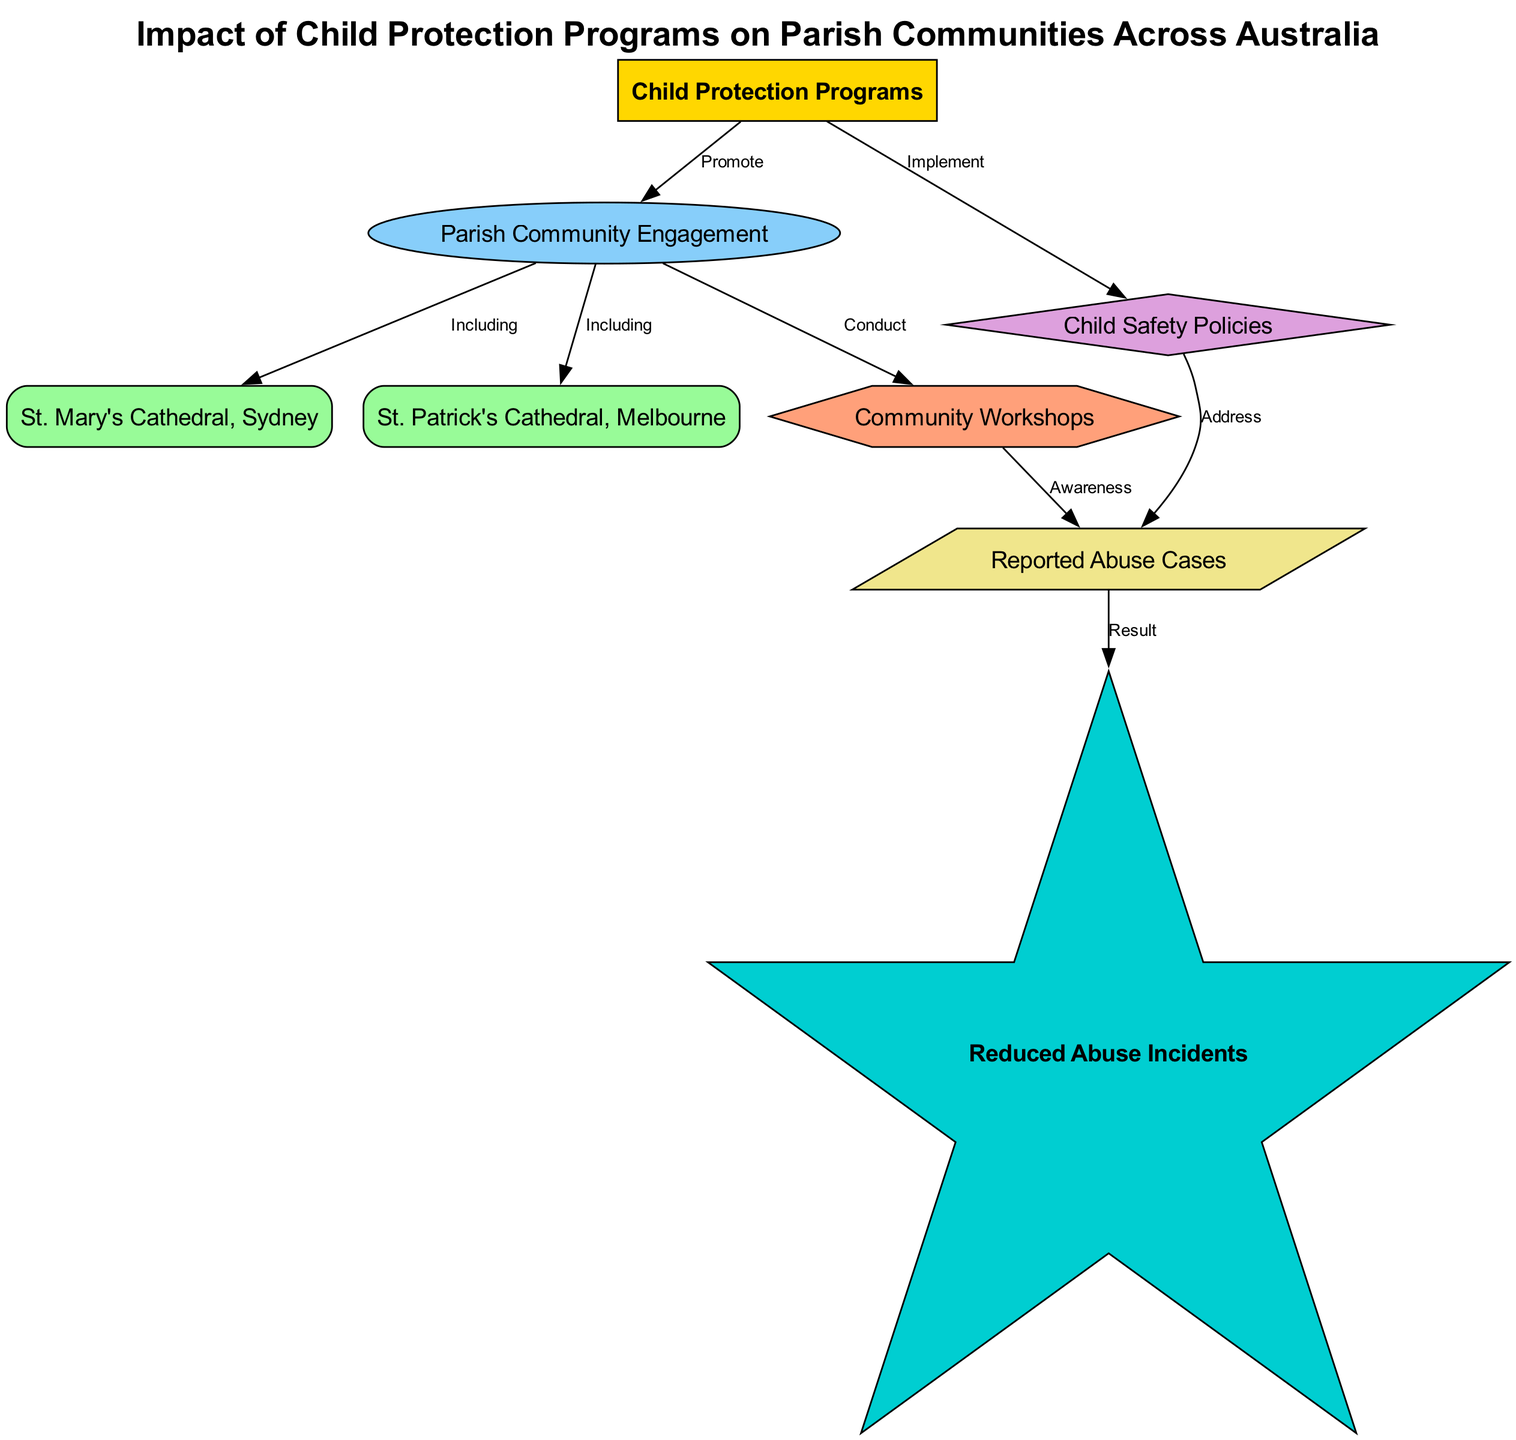What is the main node in the diagram? The main node in the diagram is identified as "Child Protection Programs," as it serves as the starting point for the relationships presented in the diagram.
Answer: Child Protection Programs How many example nodes are there? The diagram includes two example nodes: "St. Mary's Cathedral, Sydney" and "St. Patrick's Cathedral, Melbourne." Therefore, the total count of example nodes is two.
Answer: 2 What type of node is "Community Workshops"? In the diagram, "Community Workshops" is categorized as an "activity" node, indicating its role in the context of child protection programs.
Answer: activity Which node demonstrates a direct outcome of reported abuse cases? The node "Reduced Abuse Incidents" directly follows the node "Reported Abuse Cases," showing that it is an outcome resulting from efforts to address reported abuse.
Answer: Reduced Abuse Incidents What is the relationship between "Child Protection Programs" and "Child Safety Policies"? The diagram shows that "Child Protection Programs" implement "Child Safety Policies," indicating a direct action of the main node on the policy node.
Answer: Implement How does "Community Workshops" relate to "Reported Abuse Cases"? "Community Workshops" conducts activities that raise awareness, which in turn addresses "Reported Abuse Cases." Hence, there is a two-step connection between these nodes where awareness leads to addressing abuse cases.
Answer: Awareness What is the last node in the flow of the diagram? The last node in the flow of the diagram is "Reduced Abuse Incidents," which emerges from the relationships established in preceding nodes and signifies the ultimate goal of the program's impact.
Answer: Reduced Abuse Incidents Which two parishes are included in the community engagement category? The two parishes included in the community engagement category are "St. Mary's Cathedral, Sydney" and "St. Patrick's Cathedral, Melbourne," both of which are explicitly mentioned under this category in the diagram.
Answer: St. Mary's Cathedral, Sydney and St. Patrick's Cathedral, Melbourne What effect does implementing child safety policies have on abuse cases? Implementing child safety policies is shown to directly address and reduce "Reported Abuse Cases" within the diagram, indicating a causal relationship where policy implementation impacts the number of abuse cases reported.
Answer: Address 